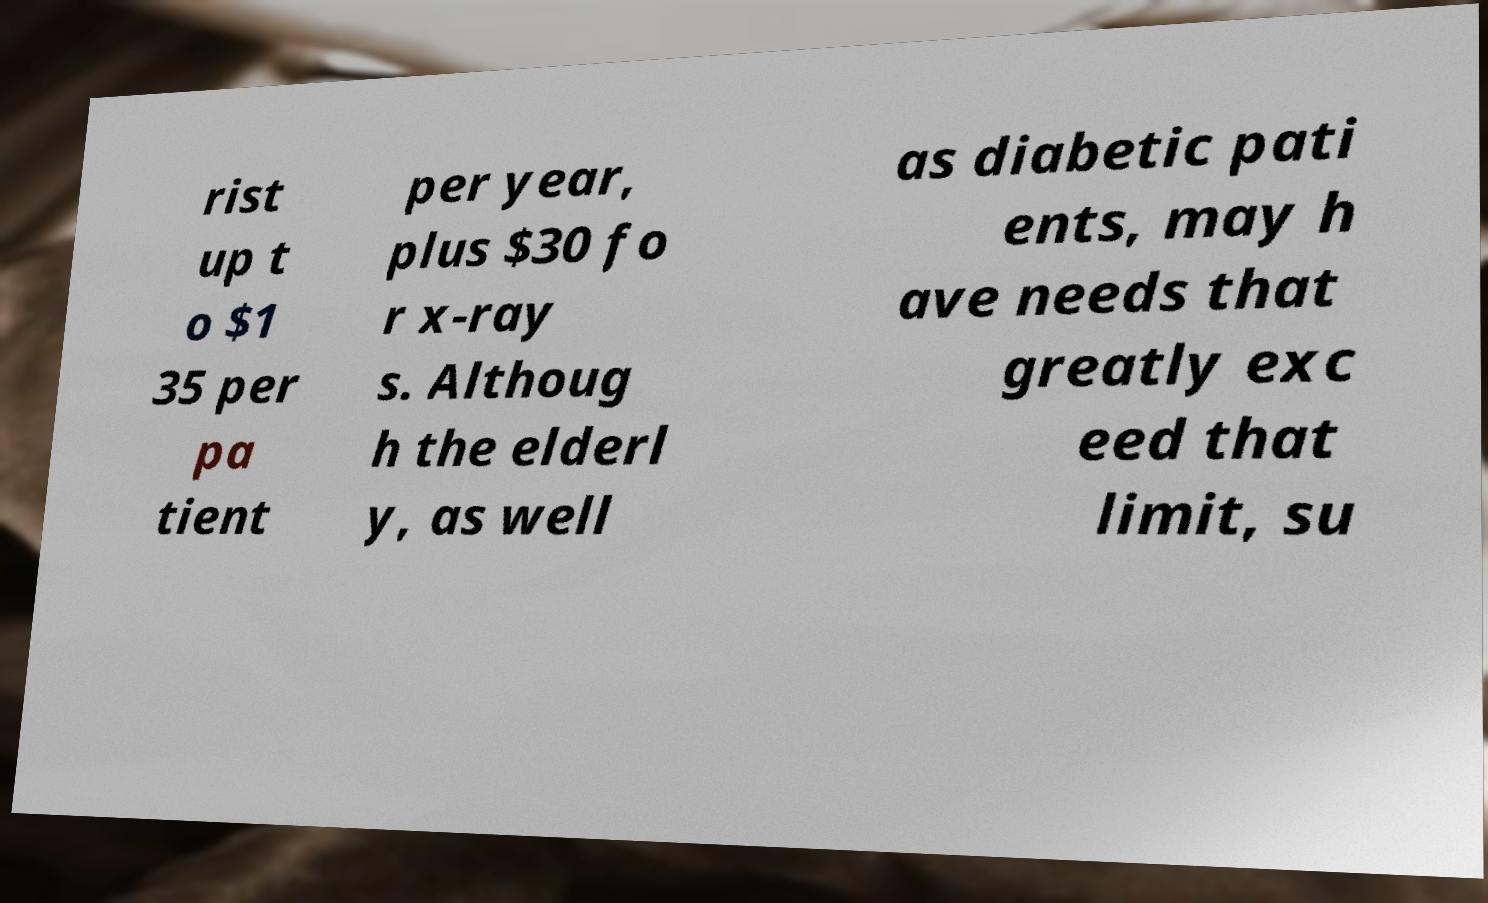Could you extract and type out the text from this image? rist up t o $1 35 per pa tient per year, plus $30 fo r x-ray s. Althoug h the elderl y, as well as diabetic pati ents, may h ave needs that greatly exc eed that limit, su 